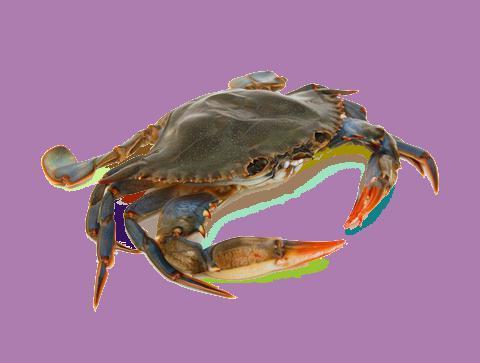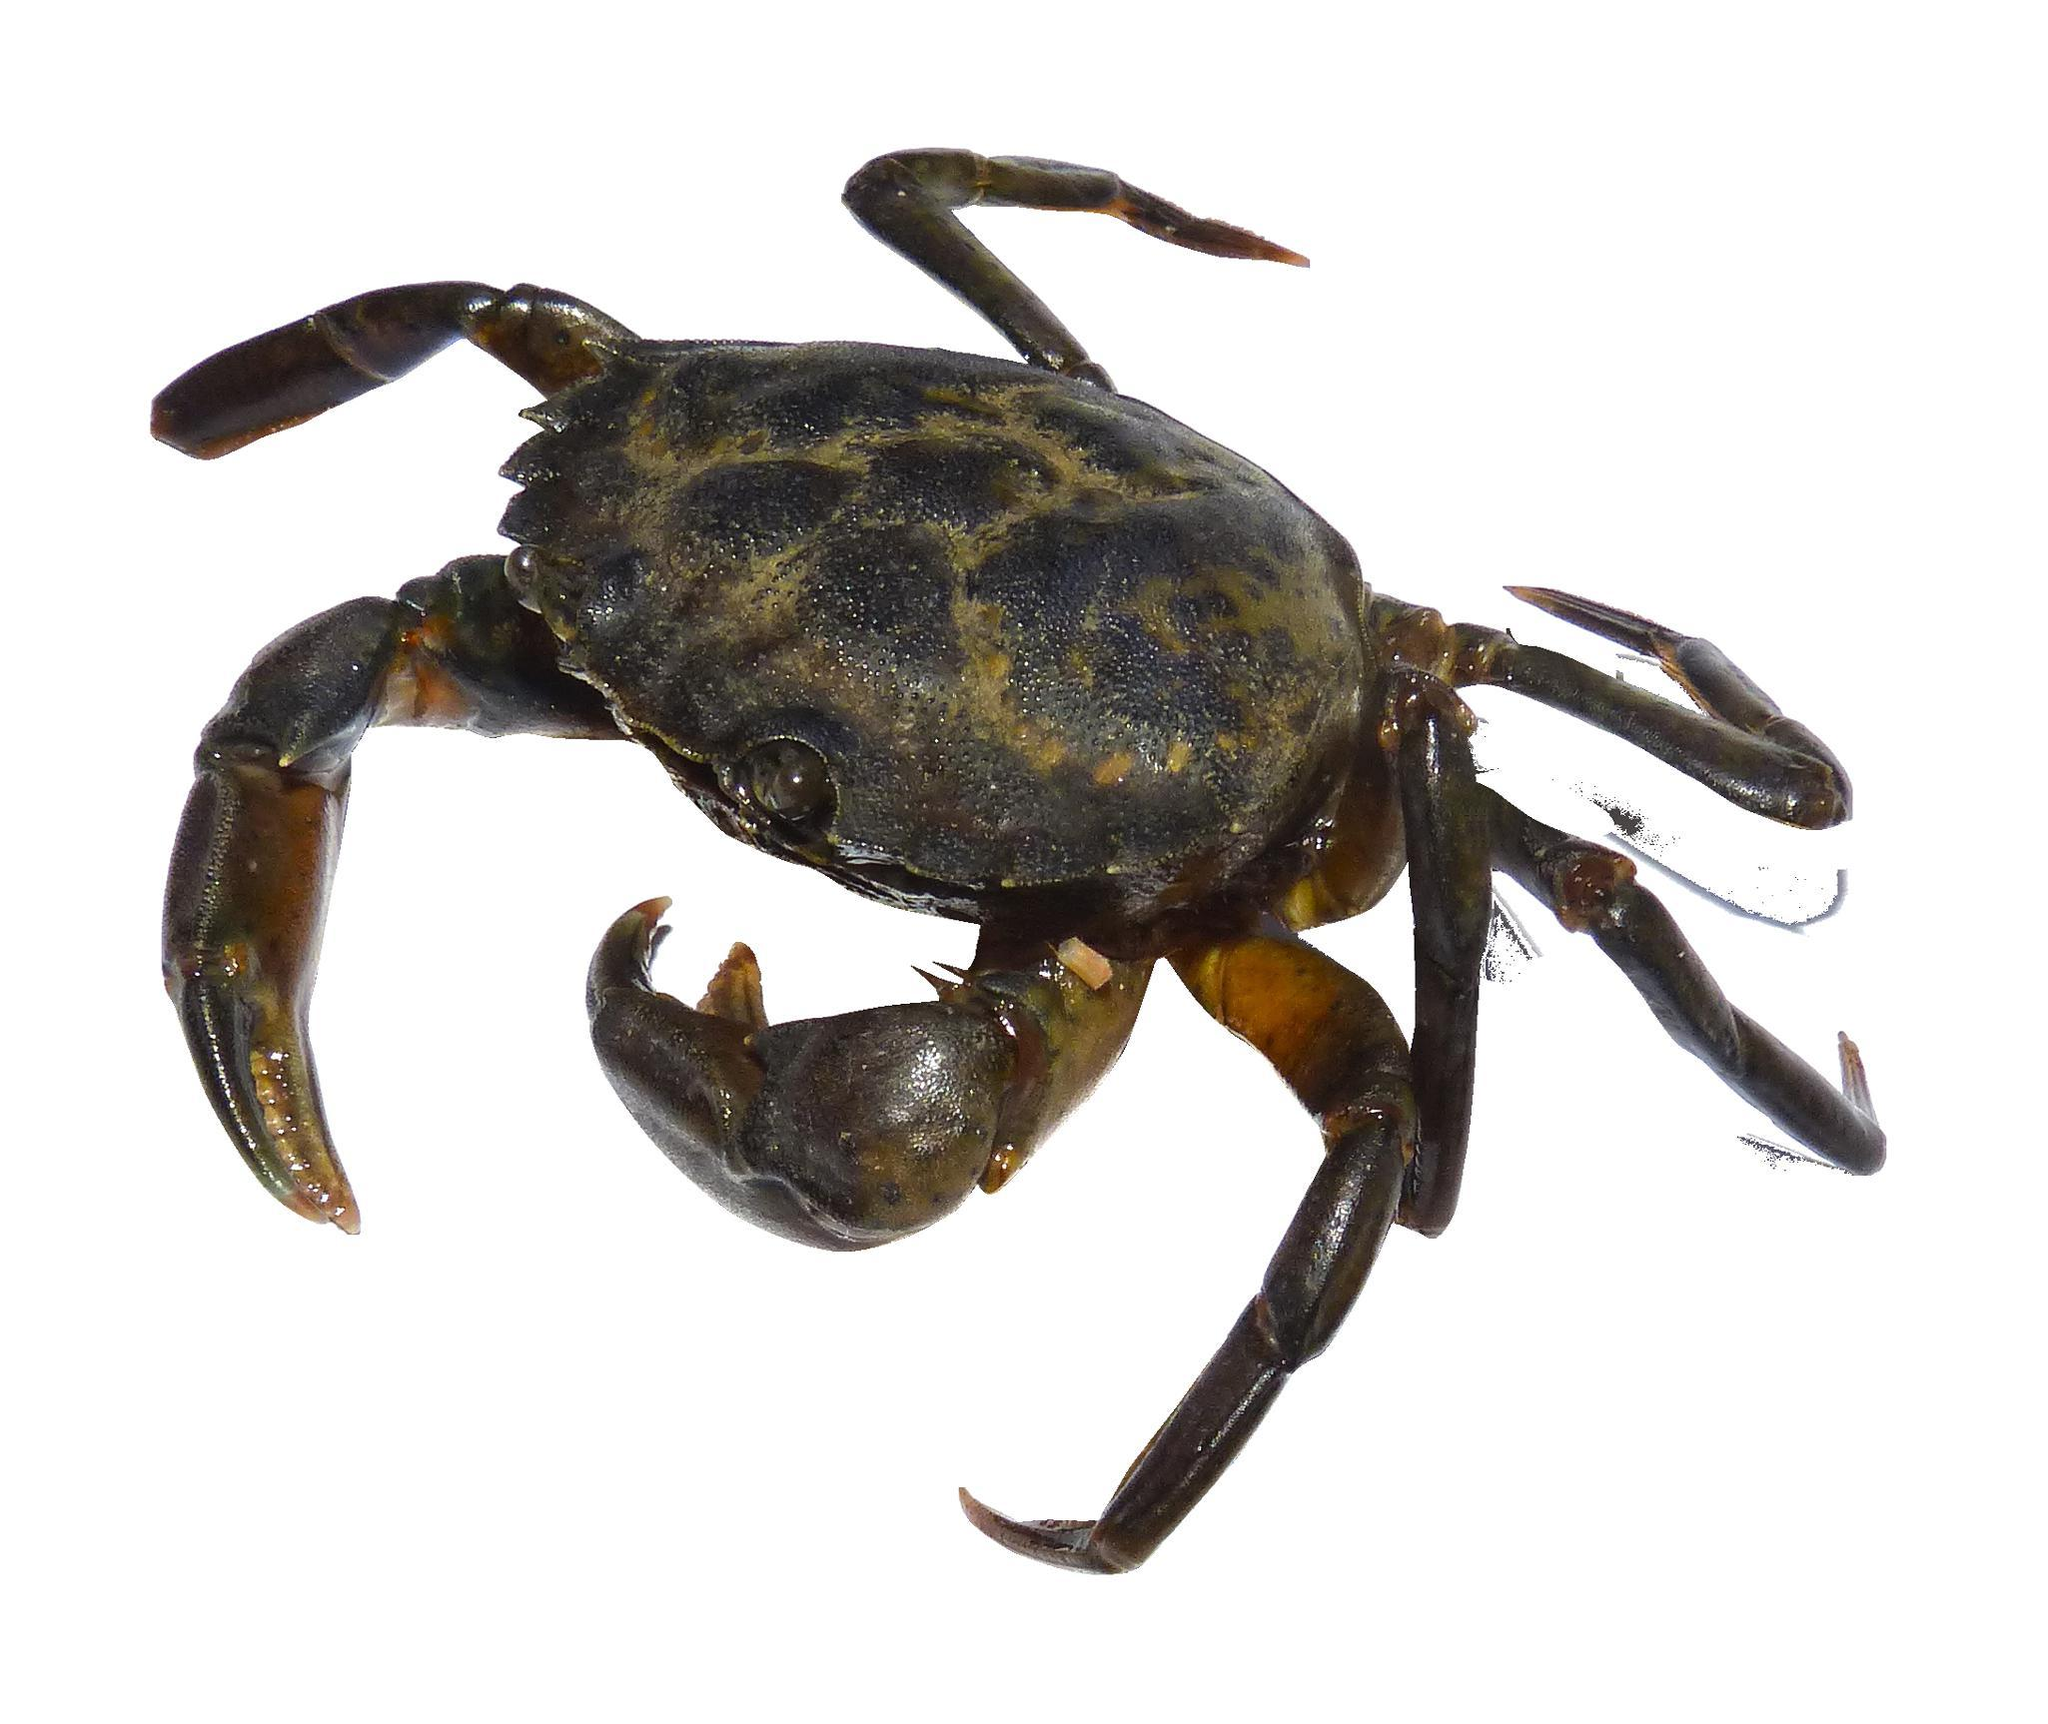The first image is the image on the left, the second image is the image on the right. Examine the images to the left and right. Is the description "there are two cooked crabs in the image pair" accurate? Answer yes or no. No. The first image is the image on the left, the second image is the image on the right. For the images shown, is this caption "Both crabs are orange." true? Answer yes or no. No. 